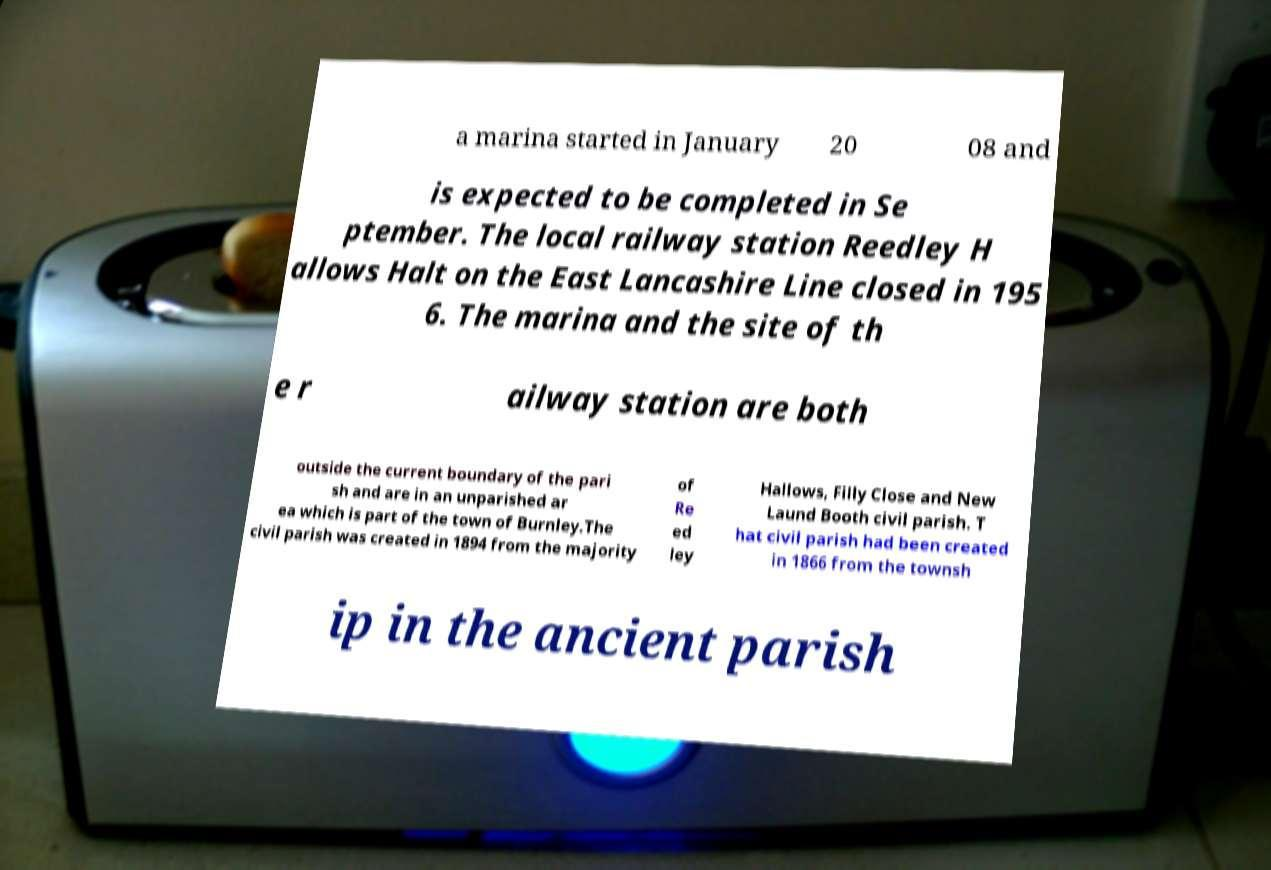Could you assist in decoding the text presented in this image and type it out clearly? a marina started in January 20 08 and is expected to be completed in Se ptember. The local railway station Reedley H allows Halt on the East Lancashire Line closed in 195 6. The marina and the site of th e r ailway station are both outside the current boundary of the pari sh and are in an unparished ar ea which is part of the town of Burnley.The civil parish was created in 1894 from the majority of Re ed ley Hallows, Filly Close and New Laund Booth civil parish. T hat civil parish had been created in 1866 from the townsh ip in the ancient parish 